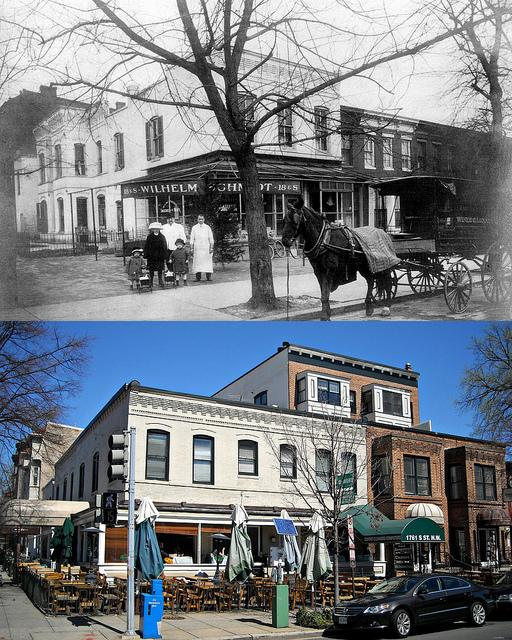Who do the umbrellas belong to? restaurant 